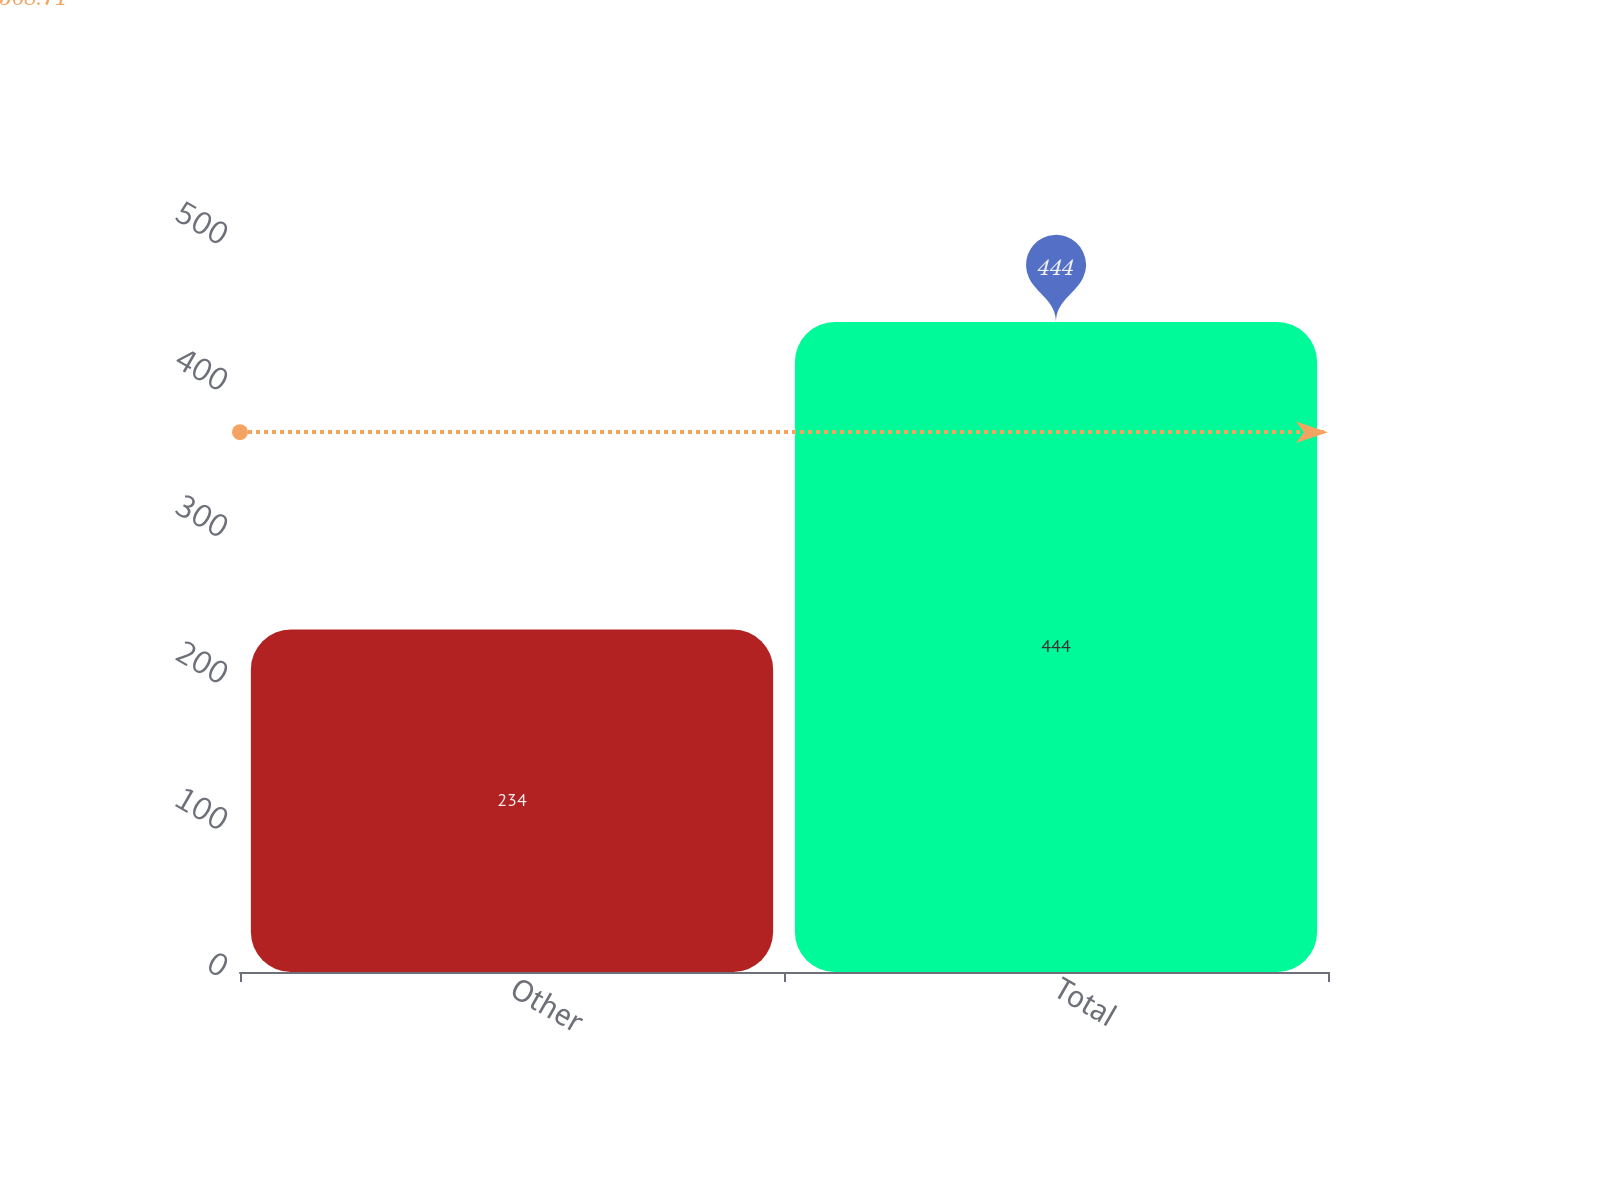<chart> <loc_0><loc_0><loc_500><loc_500><bar_chart><fcel>Other<fcel>Total<nl><fcel>234<fcel>444<nl></chart> 